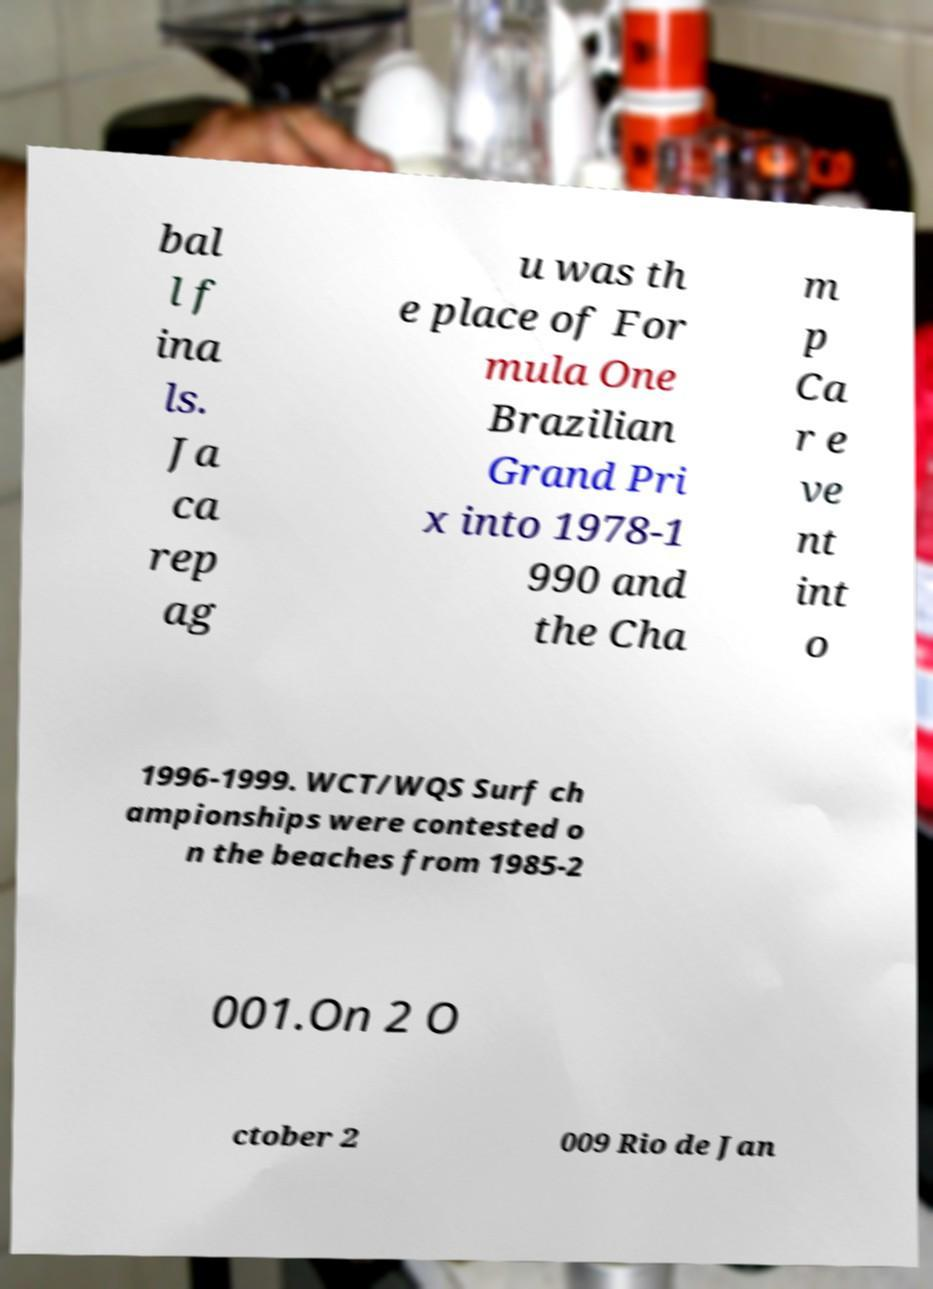What messages or text are displayed in this image? I need them in a readable, typed format. bal l f ina ls. Ja ca rep ag u was th e place of For mula One Brazilian Grand Pri x into 1978-1 990 and the Cha m p Ca r e ve nt int o 1996-1999. WCT/WQS Surf ch ampionships were contested o n the beaches from 1985-2 001.On 2 O ctober 2 009 Rio de Jan 